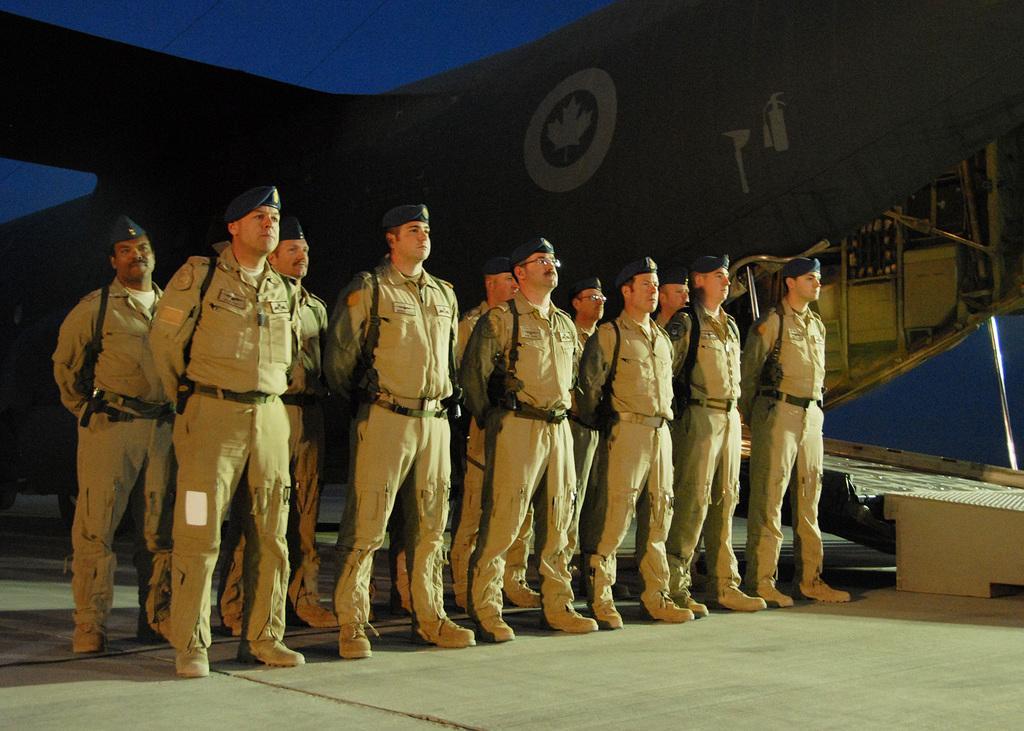Can you describe this image briefly? In this picture there are few soldiers standing and carrying a weapon on their shoulders and there are some other objects in the background. 